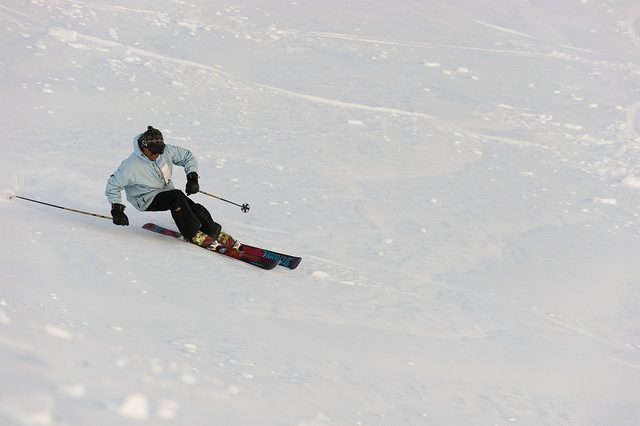Describe the objects in this image and their specific colors. I can see people in lightgray, black, darkgray, and gray tones and skis in lightgray, black, maroon, gray, and blue tones in this image. 